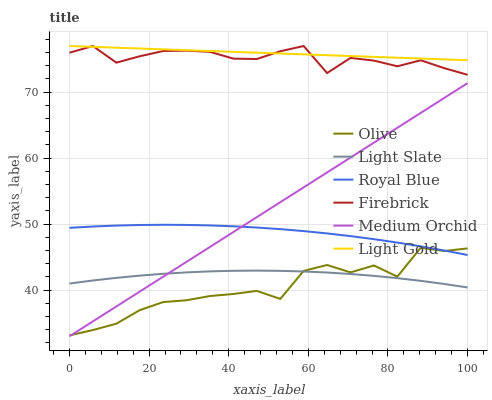Does Olive have the minimum area under the curve?
Answer yes or no. Yes. Does Light Gold have the maximum area under the curve?
Answer yes or no. Yes. Does Firebrick have the minimum area under the curve?
Answer yes or no. No. Does Firebrick have the maximum area under the curve?
Answer yes or no. No. Is Medium Orchid the smoothest?
Answer yes or no. Yes. Is Olive the roughest?
Answer yes or no. Yes. Is Firebrick the smoothest?
Answer yes or no. No. Is Firebrick the roughest?
Answer yes or no. No. Does Medium Orchid have the lowest value?
Answer yes or no. Yes. Does Firebrick have the lowest value?
Answer yes or no. No. Does Light Gold have the highest value?
Answer yes or no. Yes. Does Medium Orchid have the highest value?
Answer yes or no. No. Is Medium Orchid less than Firebrick?
Answer yes or no. Yes. Is Royal Blue greater than Light Slate?
Answer yes or no. Yes. Does Medium Orchid intersect Light Slate?
Answer yes or no. Yes. Is Medium Orchid less than Light Slate?
Answer yes or no. No. Is Medium Orchid greater than Light Slate?
Answer yes or no. No. Does Medium Orchid intersect Firebrick?
Answer yes or no. No. 